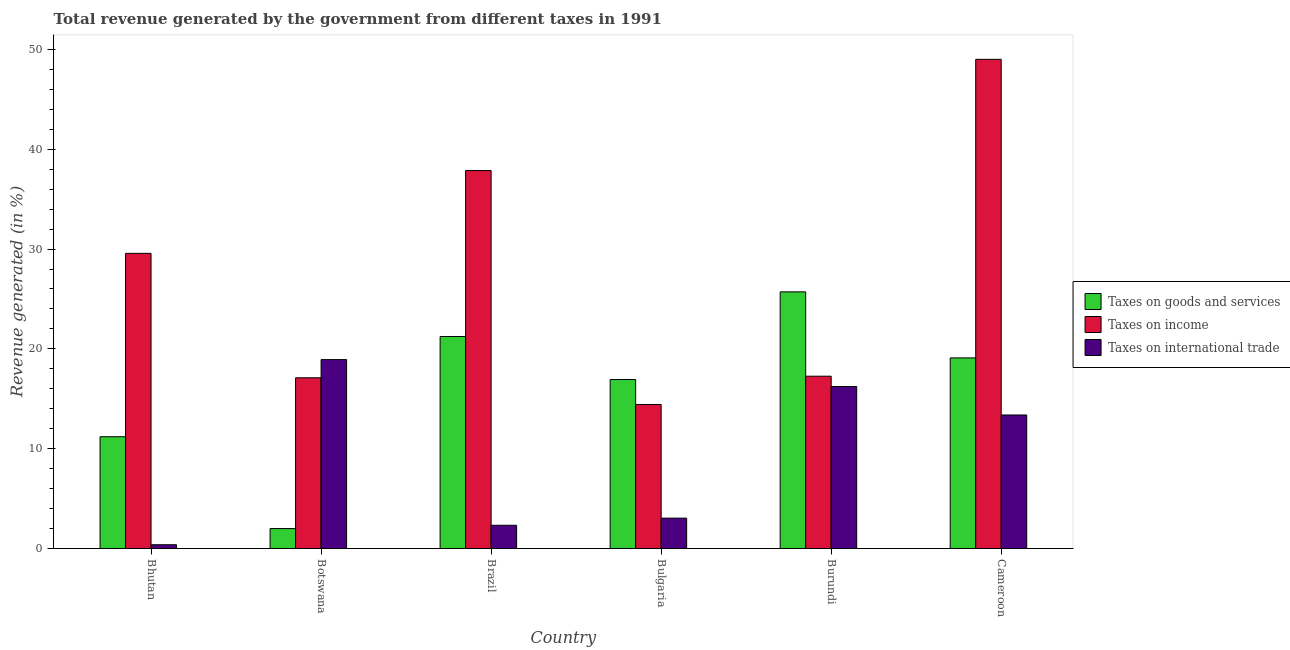How many different coloured bars are there?
Your response must be concise. 3. Are the number of bars per tick equal to the number of legend labels?
Make the answer very short. Yes. How many bars are there on the 5th tick from the left?
Provide a succinct answer. 3. What is the percentage of revenue generated by taxes on income in Brazil?
Your response must be concise. 37.87. Across all countries, what is the maximum percentage of revenue generated by taxes on income?
Provide a succinct answer. 49.01. Across all countries, what is the minimum percentage of revenue generated by tax on international trade?
Make the answer very short. 0.38. In which country was the percentage of revenue generated by taxes on goods and services maximum?
Your response must be concise. Burundi. In which country was the percentage of revenue generated by taxes on goods and services minimum?
Provide a succinct answer. Botswana. What is the total percentage of revenue generated by taxes on income in the graph?
Give a very brief answer. 165.23. What is the difference between the percentage of revenue generated by taxes on goods and services in Botswana and that in Cameroon?
Provide a succinct answer. -17.1. What is the difference between the percentage of revenue generated by taxes on goods and services in Burundi and the percentage of revenue generated by tax on international trade in Brazil?
Your response must be concise. 23.38. What is the average percentage of revenue generated by taxes on goods and services per country?
Make the answer very short. 16.03. What is the difference between the percentage of revenue generated by taxes on income and percentage of revenue generated by taxes on goods and services in Bulgaria?
Make the answer very short. -2.5. What is the ratio of the percentage of revenue generated by tax on international trade in Brazil to that in Burundi?
Your answer should be very brief. 0.14. Is the percentage of revenue generated by taxes on goods and services in Botswana less than that in Burundi?
Offer a very short reply. Yes. Is the difference between the percentage of revenue generated by tax on international trade in Burundi and Cameroon greater than the difference between the percentage of revenue generated by taxes on income in Burundi and Cameroon?
Your answer should be compact. Yes. What is the difference between the highest and the second highest percentage of revenue generated by taxes on income?
Provide a short and direct response. 11.14. What is the difference between the highest and the lowest percentage of revenue generated by taxes on income?
Ensure brevity in your answer.  34.58. Is the sum of the percentage of revenue generated by tax on international trade in Bhutan and Botswana greater than the maximum percentage of revenue generated by taxes on goods and services across all countries?
Provide a short and direct response. No. What does the 1st bar from the left in Botswana represents?
Your answer should be compact. Taxes on goods and services. What does the 2nd bar from the right in Brazil represents?
Provide a short and direct response. Taxes on income. How many bars are there?
Keep it short and to the point. 18. What is the difference between two consecutive major ticks on the Y-axis?
Your response must be concise. 10. Does the graph contain any zero values?
Offer a terse response. No. How many legend labels are there?
Your response must be concise. 3. How are the legend labels stacked?
Provide a succinct answer. Vertical. What is the title of the graph?
Your answer should be compact. Total revenue generated by the government from different taxes in 1991. Does "Infant(female)" appear as one of the legend labels in the graph?
Offer a terse response. No. What is the label or title of the Y-axis?
Offer a terse response. Revenue generated (in %). What is the Revenue generated (in %) in Taxes on goods and services in Bhutan?
Your answer should be very brief. 11.2. What is the Revenue generated (in %) in Taxes on income in Bhutan?
Offer a very short reply. 29.57. What is the Revenue generated (in %) in Taxes on international trade in Bhutan?
Your answer should be compact. 0.38. What is the Revenue generated (in %) of Taxes on goods and services in Botswana?
Offer a very short reply. 2. What is the Revenue generated (in %) of Taxes on income in Botswana?
Your answer should be compact. 17.1. What is the Revenue generated (in %) in Taxes on international trade in Botswana?
Offer a terse response. 18.92. What is the Revenue generated (in %) of Taxes on goods and services in Brazil?
Ensure brevity in your answer.  21.24. What is the Revenue generated (in %) in Taxes on income in Brazil?
Make the answer very short. 37.87. What is the Revenue generated (in %) of Taxes on international trade in Brazil?
Provide a succinct answer. 2.33. What is the Revenue generated (in %) of Taxes on goods and services in Bulgaria?
Ensure brevity in your answer.  16.93. What is the Revenue generated (in %) of Taxes on income in Bulgaria?
Your answer should be very brief. 14.43. What is the Revenue generated (in %) in Taxes on international trade in Bulgaria?
Provide a short and direct response. 3.04. What is the Revenue generated (in %) of Taxes on goods and services in Burundi?
Keep it short and to the point. 25.71. What is the Revenue generated (in %) in Taxes on income in Burundi?
Keep it short and to the point. 17.26. What is the Revenue generated (in %) of Taxes on international trade in Burundi?
Your answer should be compact. 16.22. What is the Revenue generated (in %) of Taxes on goods and services in Cameroon?
Provide a succinct answer. 19.1. What is the Revenue generated (in %) of Taxes on income in Cameroon?
Make the answer very short. 49.01. What is the Revenue generated (in %) in Taxes on international trade in Cameroon?
Keep it short and to the point. 13.38. Across all countries, what is the maximum Revenue generated (in %) in Taxes on goods and services?
Offer a very short reply. 25.71. Across all countries, what is the maximum Revenue generated (in %) in Taxes on income?
Offer a very short reply. 49.01. Across all countries, what is the maximum Revenue generated (in %) of Taxes on international trade?
Your response must be concise. 18.92. Across all countries, what is the minimum Revenue generated (in %) of Taxes on goods and services?
Offer a very short reply. 2. Across all countries, what is the minimum Revenue generated (in %) in Taxes on income?
Offer a terse response. 14.43. Across all countries, what is the minimum Revenue generated (in %) of Taxes on international trade?
Give a very brief answer. 0.38. What is the total Revenue generated (in %) of Taxes on goods and services in the graph?
Offer a very short reply. 96.17. What is the total Revenue generated (in %) in Taxes on income in the graph?
Keep it short and to the point. 165.23. What is the total Revenue generated (in %) of Taxes on international trade in the graph?
Provide a succinct answer. 54.27. What is the difference between the Revenue generated (in %) of Taxes on goods and services in Bhutan and that in Botswana?
Provide a short and direct response. 9.2. What is the difference between the Revenue generated (in %) in Taxes on income in Bhutan and that in Botswana?
Your response must be concise. 12.47. What is the difference between the Revenue generated (in %) of Taxes on international trade in Bhutan and that in Botswana?
Ensure brevity in your answer.  -18.55. What is the difference between the Revenue generated (in %) of Taxes on goods and services in Bhutan and that in Brazil?
Offer a very short reply. -10.04. What is the difference between the Revenue generated (in %) of Taxes on income in Bhutan and that in Brazil?
Your answer should be very brief. -8.3. What is the difference between the Revenue generated (in %) of Taxes on international trade in Bhutan and that in Brazil?
Provide a short and direct response. -1.95. What is the difference between the Revenue generated (in %) in Taxes on goods and services in Bhutan and that in Bulgaria?
Give a very brief answer. -5.73. What is the difference between the Revenue generated (in %) of Taxes on income in Bhutan and that in Bulgaria?
Provide a short and direct response. 15.14. What is the difference between the Revenue generated (in %) in Taxes on international trade in Bhutan and that in Bulgaria?
Make the answer very short. -2.67. What is the difference between the Revenue generated (in %) of Taxes on goods and services in Bhutan and that in Burundi?
Give a very brief answer. -14.51. What is the difference between the Revenue generated (in %) of Taxes on income in Bhutan and that in Burundi?
Offer a very short reply. 12.31. What is the difference between the Revenue generated (in %) in Taxes on international trade in Bhutan and that in Burundi?
Give a very brief answer. -15.85. What is the difference between the Revenue generated (in %) in Taxes on goods and services in Bhutan and that in Cameroon?
Your answer should be compact. -7.9. What is the difference between the Revenue generated (in %) of Taxes on income in Bhutan and that in Cameroon?
Your answer should be compact. -19.44. What is the difference between the Revenue generated (in %) in Taxes on international trade in Bhutan and that in Cameroon?
Provide a short and direct response. -13. What is the difference between the Revenue generated (in %) of Taxes on goods and services in Botswana and that in Brazil?
Make the answer very short. -19.24. What is the difference between the Revenue generated (in %) of Taxes on income in Botswana and that in Brazil?
Your response must be concise. -20.76. What is the difference between the Revenue generated (in %) of Taxes on international trade in Botswana and that in Brazil?
Make the answer very short. 16.6. What is the difference between the Revenue generated (in %) in Taxes on goods and services in Botswana and that in Bulgaria?
Provide a short and direct response. -14.93. What is the difference between the Revenue generated (in %) in Taxes on income in Botswana and that in Bulgaria?
Keep it short and to the point. 2.67. What is the difference between the Revenue generated (in %) of Taxes on international trade in Botswana and that in Bulgaria?
Offer a very short reply. 15.88. What is the difference between the Revenue generated (in %) in Taxes on goods and services in Botswana and that in Burundi?
Ensure brevity in your answer.  -23.71. What is the difference between the Revenue generated (in %) of Taxes on income in Botswana and that in Burundi?
Keep it short and to the point. -0.16. What is the difference between the Revenue generated (in %) in Taxes on international trade in Botswana and that in Burundi?
Provide a succinct answer. 2.7. What is the difference between the Revenue generated (in %) in Taxes on goods and services in Botswana and that in Cameroon?
Provide a short and direct response. -17.1. What is the difference between the Revenue generated (in %) in Taxes on income in Botswana and that in Cameroon?
Keep it short and to the point. -31.91. What is the difference between the Revenue generated (in %) in Taxes on international trade in Botswana and that in Cameroon?
Your response must be concise. 5.55. What is the difference between the Revenue generated (in %) of Taxes on goods and services in Brazil and that in Bulgaria?
Provide a short and direct response. 4.31. What is the difference between the Revenue generated (in %) of Taxes on income in Brazil and that in Bulgaria?
Your response must be concise. 23.44. What is the difference between the Revenue generated (in %) of Taxes on international trade in Brazil and that in Bulgaria?
Offer a terse response. -0.71. What is the difference between the Revenue generated (in %) in Taxes on goods and services in Brazil and that in Burundi?
Provide a succinct answer. -4.47. What is the difference between the Revenue generated (in %) in Taxes on income in Brazil and that in Burundi?
Offer a terse response. 20.6. What is the difference between the Revenue generated (in %) in Taxes on international trade in Brazil and that in Burundi?
Provide a short and direct response. -13.9. What is the difference between the Revenue generated (in %) in Taxes on goods and services in Brazil and that in Cameroon?
Keep it short and to the point. 2.14. What is the difference between the Revenue generated (in %) of Taxes on income in Brazil and that in Cameroon?
Your answer should be very brief. -11.14. What is the difference between the Revenue generated (in %) of Taxes on international trade in Brazil and that in Cameroon?
Your answer should be compact. -11.05. What is the difference between the Revenue generated (in %) in Taxes on goods and services in Bulgaria and that in Burundi?
Provide a short and direct response. -8.78. What is the difference between the Revenue generated (in %) of Taxes on income in Bulgaria and that in Burundi?
Your response must be concise. -2.83. What is the difference between the Revenue generated (in %) of Taxes on international trade in Bulgaria and that in Burundi?
Ensure brevity in your answer.  -13.18. What is the difference between the Revenue generated (in %) of Taxes on goods and services in Bulgaria and that in Cameroon?
Keep it short and to the point. -2.17. What is the difference between the Revenue generated (in %) of Taxes on income in Bulgaria and that in Cameroon?
Keep it short and to the point. -34.58. What is the difference between the Revenue generated (in %) in Taxes on international trade in Bulgaria and that in Cameroon?
Make the answer very short. -10.33. What is the difference between the Revenue generated (in %) of Taxes on goods and services in Burundi and that in Cameroon?
Offer a terse response. 6.61. What is the difference between the Revenue generated (in %) in Taxes on income in Burundi and that in Cameroon?
Provide a short and direct response. -31.75. What is the difference between the Revenue generated (in %) in Taxes on international trade in Burundi and that in Cameroon?
Your answer should be very brief. 2.85. What is the difference between the Revenue generated (in %) in Taxes on goods and services in Bhutan and the Revenue generated (in %) in Taxes on income in Botswana?
Give a very brief answer. -5.91. What is the difference between the Revenue generated (in %) in Taxes on goods and services in Bhutan and the Revenue generated (in %) in Taxes on international trade in Botswana?
Ensure brevity in your answer.  -7.73. What is the difference between the Revenue generated (in %) of Taxes on income in Bhutan and the Revenue generated (in %) of Taxes on international trade in Botswana?
Ensure brevity in your answer.  10.64. What is the difference between the Revenue generated (in %) in Taxes on goods and services in Bhutan and the Revenue generated (in %) in Taxes on income in Brazil?
Offer a terse response. -26.67. What is the difference between the Revenue generated (in %) in Taxes on goods and services in Bhutan and the Revenue generated (in %) in Taxes on international trade in Brazil?
Make the answer very short. 8.87. What is the difference between the Revenue generated (in %) in Taxes on income in Bhutan and the Revenue generated (in %) in Taxes on international trade in Brazil?
Provide a succinct answer. 27.24. What is the difference between the Revenue generated (in %) of Taxes on goods and services in Bhutan and the Revenue generated (in %) of Taxes on income in Bulgaria?
Your answer should be very brief. -3.23. What is the difference between the Revenue generated (in %) of Taxes on goods and services in Bhutan and the Revenue generated (in %) of Taxes on international trade in Bulgaria?
Provide a short and direct response. 8.16. What is the difference between the Revenue generated (in %) of Taxes on income in Bhutan and the Revenue generated (in %) of Taxes on international trade in Bulgaria?
Offer a terse response. 26.53. What is the difference between the Revenue generated (in %) in Taxes on goods and services in Bhutan and the Revenue generated (in %) in Taxes on income in Burundi?
Your answer should be compact. -6.07. What is the difference between the Revenue generated (in %) of Taxes on goods and services in Bhutan and the Revenue generated (in %) of Taxes on international trade in Burundi?
Your answer should be very brief. -5.03. What is the difference between the Revenue generated (in %) in Taxes on income in Bhutan and the Revenue generated (in %) in Taxes on international trade in Burundi?
Ensure brevity in your answer.  13.34. What is the difference between the Revenue generated (in %) in Taxes on goods and services in Bhutan and the Revenue generated (in %) in Taxes on income in Cameroon?
Make the answer very short. -37.81. What is the difference between the Revenue generated (in %) of Taxes on goods and services in Bhutan and the Revenue generated (in %) of Taxes on international trade in Cameroon?
Provide a short and direct response. -2.18. What is the difference between the Revenue generated (in %) in Taxes on income in Bhutan and the Revenue generated (in %) in Taxes on international trade in Cameroon?
Your answer should be very brief. 16.19. What is the difference between the Revenue generated (in %) of Taxes on goods and services in Botswana and the Revenue generated (in %) of Taxes on income in Brazil?
Ensure brevity in your answer.  -35.87. What is the difference between the Revenue generated (in %) of Taxes on goods and services in Botswana and the Revenue generated (in %) of Taxes on international trade in Brazil?
Offer a very short reply. -0.33. What is the difference between the Revenue generated (in %) in Taxes on income in Botswana and the Revenue generated (in %) in Taxes on international trade in Brazil?
Give a very brief answer. 14.78. What is the difference between the Revenue generated (in %) in Taxes on goods and services in Botswana and the Revenue generated (in %) in Taxes on income in Bulgaria?
Give a very brief answer. -12.43. What is the difference between the Revenue generated (in %) in Taxes on goods and services in Botswana and the Revenue generated (in %) in Taxes on international trade in Bulgaria?
Give a very brief answer. -1.05. What is the difference between the Revenue generated (in %) of Taxes on income in Botswana and the Revenue generated (in %) of Taxes on international trade in Bulgaria?
Offer a terse response. 14.06. What is the difference between the Revenue generated (in %) of Taxes on goods and services in Botswana and the Revenue generated (in %) of Taxes on income in Burundi?
Give a very brief answer. -15.27. What is the difference between the Revenue generated (in %) of Taxes on goods and services in Botswana and the Revenue generated (in %) of Taxes on international trade in Burundi?
Make the answer very short. -14.23. What is the difference between the Revenue generated (in %) of Taxes on income in Botswana and the Revenue generated (in %) of Taxes on international trade in Burundi?
Your response must be concise. 0.88. What is the difference between the Revenue generated (in %) of Taxes on goods and services in Botswana and the Revenue generated (in %) of Taxes on income in Cameroon?
Give a very brief answer. -47.01. What is the difference between the Revenue generated (in %) in Taxes on goods and services in Botswana and the Revenue generated (in %) in Taxes on international trade in Cameroon?
Keep it short and to the point. -11.38. What is the difference between the Revenue generated (in %) of Taxes on income in Botswana and the Revenue generated (in %) of Taxes on international trade in Cameroon?
Provide a succinct answer. 3.73. What is the difference between the Revenue generated (in %) in Taxes on goods and services in Brazil and the Revenue generated (in %) in Taxes on income in Bulgaria?
Your answer should be compact. 6.81. What is the difference between the Revenue generated (in %) of Taxes on goods and services in Brazil and the Revenue generated (in %) of Taxes on international trade in Bulgaria?
Offer a very short reply. 18.2. What is the difference between the Revenue generated (in %) of Taxes on income in Brazil and the Revenue generated (in %) of Taxes on international trade in Bulgaria?
Offer a terse response. 34.82. What is the difference between the Revenue generated (in %) of Taxes on goods and services in Brazil and the Revenue generated (in %) of Taxes on income in Burundi?
Keep it short and to the point. 3.98. What is the difference between the Revenue generated (in %) of Taxes on goods and services in Brazil and the Revenue generated (in %) of Taxes on international trade in Burundi?
Keep it short and to the point. 5.02. What is the difference between the Revenue generated (in %) in Taxes on income in Brazil and the Revenue generated (in %) in Taxes on international trade in Burundi?
Give a very brief answer. 21.64. What is the difference between the Revenue generated (in %) in Taxes on goods and services in Brazil and the Revenue generated (in %) in Taxes on income in Cameroon?
Your answer should be compact. -27.77. What is the difference between the Revenue generated (in %) of Taxes on goods and services in Brazil and the Revenue generated (in %) of Taxes on international trade in Cameroon?
Provide a succinct answer. 7.86. What is the difference between the Revenue generated (in %) in Taxes on income in Brazil and the Revenue generated (in %) in Taxes on international trade in Cameroon?
Ensure brevity in your answer.  24.49. What is the difference between the Revenue generated (in %) of Taxes on goods and services in Bulgaria and the Revenue generated (in %) of Taxes on income in Burundi?
Offer a terse response. -0.33. What is the difference between the Revenue generated (in %) in Taxes on goods and services in Bulgaria and the Revenue generated (in %) in Taxes on international trade in Burundi?
Provide a succinct answer. 0.7. What is the difference between the Revenue generated (in %) in Taxes on income in Bulgaria and the Revenue generated (in %) in Taxes on international trade in Burundi?
Offer a terse response. -1.8. What is the difference between the Revenue generated (in %) of Taxes on goods and services in Bulgaria and the Revenue generated (in %) of Taxes on income in Cameroon?
Make the answer very short. -32.08. What is the difference between the Revenue generated (in %) in Taxes on goods and services in Bulgaria and the Revenue generated (in %) in Taxes on international trade in Cameroon?
Your answer should be compact. 3.55. What is the difference between the Revenue generated (in %) of Taxes on income in Bulgaria and the Revenue generated (in %) of Taxes on international trade in Cameroon?
Give a very brief answer. 1.05. What is the difference between the Revenue generated (in %) in Taxes on goods and services in Burundi and the Revenue generated (in %) in Taxes on income in Cameroon?
Give a very brief answer. -23.3. What is the difference between the Revenue generated (in %) in Taxes on goods and services in Burundi and the Revenue generated (in %) in Taxes on international trade in Cameroon?
Offer a terse response. 12.33. What is the difference between the Revenue generated (in %) of Taxes on income in Burundi and the Revenue generated (in %) of Taxes on international trade in Cameroon?
Give a very brief answer. 3.89. What is the average Revenue generated (in %) in Taxes on goods and services per country?
Offer a terse response. 16.03. What is the average Revenue generated (in %) of Taxes on income per country?
Ensure brevity in your answer.  27.54. What is the average Revenue generated (in %) in Taxes on international trade per country?
Offer a terse response. 9.04. What is the difference between the Revenue generated (in %) in Taxes on goods and services and Revenue generated (in %) in Taxes on income in Bhutan?
Make the answer very short. -18.37. What is the difference between the Revenue generated (in %) in Taxes on goods and services and Revenue generated (in %) in Taxes on international trade in Bhutan?
Provide a succinct answer. 10.82. What is the difference between the Revenue generated (in %) in Taxes on income and Revenue generated (in %) in Taxes on international trade in Bhutan?
Offer a terse response. 29.19. What is the difference between the Revenue generated (in %) of Taxes on goods and services and Revenue generated (in %) of Taxes on income in Botswana?
Make the answer very short. -15.11. What is the difference between the Revenue generated (in %) of Taxes on goods and services and Revenue generated (in %) of Taxes on international trade in Botswana?
Provide a succinct answer. -16.93. What is the difference between the Revenue generated (in %) in Taxes on income and Revenue generated (in %) in Taxes on international trade in Botswana?
Give a very brief answer. -1.82. What is the difference between the Revenue generated (in %) of Taxes on goods and services and Revenue generated (in %) of Taxes on income in Brazil?
Give a very brief answer. -16.63. What is the difference between the Revenue generated (in %) of Taxes on goods and services and Revenue generated (in %) of Taxes on international trade in Brazil?
Make the answer very short. 18.91. What is the difference between the Revenue generated (in %) in Taxes on income and Revenue generated (in %) in Taxes on international trade in Brazil?
Your answer should be compact. 35.54. What is the difference between the Revenue generated (in %) in Taxes on goods and services and Revenue generated (in %) in Taxes on income in Bulgaria?
Your answer should be compact. 2.5. What is the difference between the Revenue generated (in %) of Taxes on goods and services and Revenue generated (in %) of Taxes on international trade in Bulgaria?
Offer a very short reply. 13.89. What is the difference between the Revenue generated (in %) in Taxes on income and Revenue generated (in %) in Taxes on international trade in Bulgaria?
Give a very brief answer. 11.39. What is the difference between the Revenue generated (in %) of Taxes on goods and services and Revenue generated (in %) of Taxes on income in Burundi?
Offer a very short reply. 8.45. What is the difference between the Revenue generated (in %) of Taxes on goods and services and Revenue generated (in %) of Taxes on international trade in Burundi?
Ensure brevity in your answer.  9.48. What is the difference between the Revenue generated (in %) of Taxes on income and Revenue generated (in %) of Taxes on international trade in Burundi?
Give a very brief answer. 1.04. What is the difference between the Revenue generated (in %) in Taxes on goods and services and Revenue generated (in %) in Taxes on income in Cameroon?
Offer a terse response. -29.91. What is the difference between the Revenue generated (in %) of Taxes on goods and services and Revenue generated (in %) of Taxes on international trade in Cameroon?
Your answer should be very brief. 5.72. What is the difference between the Revenue generated (in %) in Taxes on income and Revenue generated (in %) in Taxes on international trade in Cameroon?
Provide a short and direct response. 35.63. What is the ratio of the Revenue generated (in %) of Taxes on goods and services in Bhutan to that in Botswana?
Offer a terse response. 5.61. What is the ratio of the Revenue generated (in %) in Taxes on income in Bhutan to that in Botswana?
Make the answer very short. 1.73. What is the ratio of the Revenue generated (in %) in Taxes on international trade in Bhutan to that in Botswana?
Make the answer very short. 0.02. What is the ratio of the Revenue generated (in %) in Taxes on goods and services in Bhutan to that in Brazil?
Offer a terse response. 0.53. What is the ratio of the Revenue generated (in %) in Taxes on income in Bhutan to that in Brazil?
Your answer should be very brief. 0.78. What is the ratio of the Revenue generated (in %) of Taxes on international trade in Bhutan to that in Brazil?
Give a very brief answer. 0.16. What is the ratio of the Revenue generated (in %) in Taxes on goods and services in Bhutan to that in Bulgaria?
Provide a succinct answer. 0.66. What is the ratio of the Revenue generated (in %) of Taxes on income in Bhutan to that in Bulgaria?
Provide a short and direct response. 2.05. What is the ratio of the Revenue generated (in %) in Taxes on international trade in Bhutan to that in Bulgaria?
Make the answer very short. 0.12. What is the ratio of the Revenue generated (in %) in Taxes on goods and services in Bhutan to that in Burundi?
Keep it short and to the point. 0.44. What is the ratio of the Revenue generated (in %) in Taxes on income in Bhutan to that in Burundi?
Provide a short and direct response. 1.71. What is the ratio of the Revenue generated (in %) of Taxes on international trade in Bhutan to that in Burundi?
Ensure brevity in your answer.  0.02. What is the ratio of the Revenue generated (in %) in Taxes on goods and services in Bhutan to that in Cameroon?
Your answer should be very brief. 0.59. What is the ratio of the Revenue generated (in %) of Taxes on income in Bhutan to that in Cameroon?
Provide a succinct answer. 0.6. What is the ratio of the Revenue generated (in %) of Taxes on international trade in Bhutan to that in Cameroon?
Offer a very short reply. 0.03. What is the ratio of the Revenue generated (in %) of Taxes on goods and services in Botswana to that in Brazil?
Your response must be concise. 0.09. What is the ratio of the Revenue generated (in %) of Taxes on income in Botswana to that in Brazil?
Offer a very short reply. 0.45. What is the ratio of the Revenue generated (in %) in Taxes on international trade in Botswana to that in Brazil?
Your response must be concise. 8.13. What is the ratio of the Revenue generated (in %) in Taxes on goods and services in Botswana to that in Bulgaria?
Your answer should be very brief. 0.12. What is the ratio of the Revenue generated (in %) of Taxes on income in Botswana to that in Bulgaria?
Keep it short and to the point. 1.19. What is the ratio of the Revenue generated (in %) in Taxes on international trade in Botswana to that in Bulgaria?
Provide a succinct answer. 6.22. What is the ratio of the Revenue generated (in %) in Taxes on goods and services in Botswana to that in Burundi?
Provide a short and direct response. 0.08. What is the ratio of the Revenue generated (in %) of Taxes on income in Botswana to that in Burundi?
Offer a very short reply. 0.99. What is the ratio of the Revenue generated (in %) in Taxes on international trade in Botswana to that in Burundi?
Give a very brief answer. 1.17. What is the ratio of the Revenue generated (in %) of Taxes on goods and services in Botswana to that in Cameroon?
Make the answer very short. 0.1. What is the ratio of the Revenue generated (in %) of Taxes on income in Botswana to that in Cameroon?
Make the answer very short. 0.35. What is the ratio of the Revenue generated (in %) of Taxes on international trade in Botswana to that in Cameroon?
Offer a terse response. 1.41. What is the ratio of the Revenue generated (in %) in Taxes on goods and services in Brazil to that in Bulgaria?
Keep it short and to the point. 1.25. What is the ratio of the Revenue generated (in %) in Taxes on income in Brazil to that in Bulgaria?
Give a very brief answer. 2.62. What is the ratio of the Revenue generated (in %) in Taxes on international trade in Brazil to that in Bulgaria?
Offer a terse response. 0.76. What is the ratio of the Revenue generated (in %) in Taxes on goods and services in Brazil to that in Burundi?
Ensure brevity in your answer.  0.83. What is the ratio of the Revenue generated (in %) of Taxes on income in Brazil to that in Burundi?
Your answer should be compact. 2.19. What is the ratio of the Revenue generated (in %) of Taxes on international trade in Brazil to that in Burundi?
Ensure brevity in your answer.  0.14. What is the ratio of the Revenue generated (in %) in Taxes on goods and services in Brazil to that in Cameroon?
Offer a terse response. 1.11. What is the ratio of the Revenue generated (in %) in Taxes on income in Brazil to that in Cameroon?
Ensure brevity in your answer.  0.77. What is the ratio of the Revenue generated (in %) in Taxes on international trade in Brazil to that in Cameroon?
Provide a short and direct response. 0.17. What is the ratio of the Revenue generated (in %) of Taxes on goods and services in Bulgaria to that in Burundi?
Ensure brevity in your answer.  0.66. What is the ratio of the Revenue generated (in %) of Taxes on income in Bulgaria to that in Burundi?
Make the answer very short. 0.84. What is the ratio of the Revenue generated (in %) in Taxes on international trade in Bulgaria to that in Burundi?
Keep it short and to the point. 0.19. What is the ratio of the Revenue generated (in %) of Taxes on goods and services in Bulgaria to that in Cameroon?
Keep it short and to the point. 0.89. What is the ratio of the Revenue generated (in %) in Taxes on income in Bulgaria to that in Cameroon?
Your response must be concise. 0.29. What is the ratio of the Revenue generated (in %) of Taxes on international trade in Bulgaria to that in Cameroon?
Offer a very short reply. 0.23. What is the ratio of the Revenue generated (in %) of Taxes on goods and services in Burundi to that in Cameroon?
Give a very brief answer. 1.35. What is the ratio of the Revenue generated (in %) in Taxes on income in Burundi to that in Cameroon?
Provide a short and direct response. 0.35. What is the ratio of the Revenue generated (in %) in Taxes on international trade in Burundi to that in Cameroon?
Offer a terse response. 1.21. What is the difference between the highest and the second highest Revenue generated (in %) in Taxes on goods and services?
Your answer should be compact. 4.47. What is the difference between the highest and the second highest Revenue generated (in %) of Taxes on income?
Offer a terse response. 11.14. What is the difference between the highest and the second highest Revenue generated (in %) in Taxes on international trade?
Keep it short and to the point. 2.7. What is the difference between the highest and the lowest Revenue generated (in %) of Taxes on goods and services?
Give a very brief answer. 23.71. What is the difference between the highest and the lowest Revenue generated (in %) of Taxes on income?
Provide a short and direct response. 34.58. What is the difference between the highest and the lowest Revenue generated (in %) of Taxes on international trade?
Your answer should be compact. 18.55. 